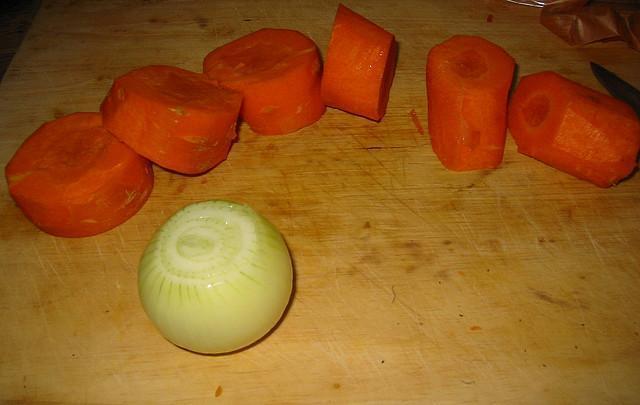How many carrots are there?
Give a very brief answer. 5. How many sandwich on the plate?
Give a very brief answer. 0. 